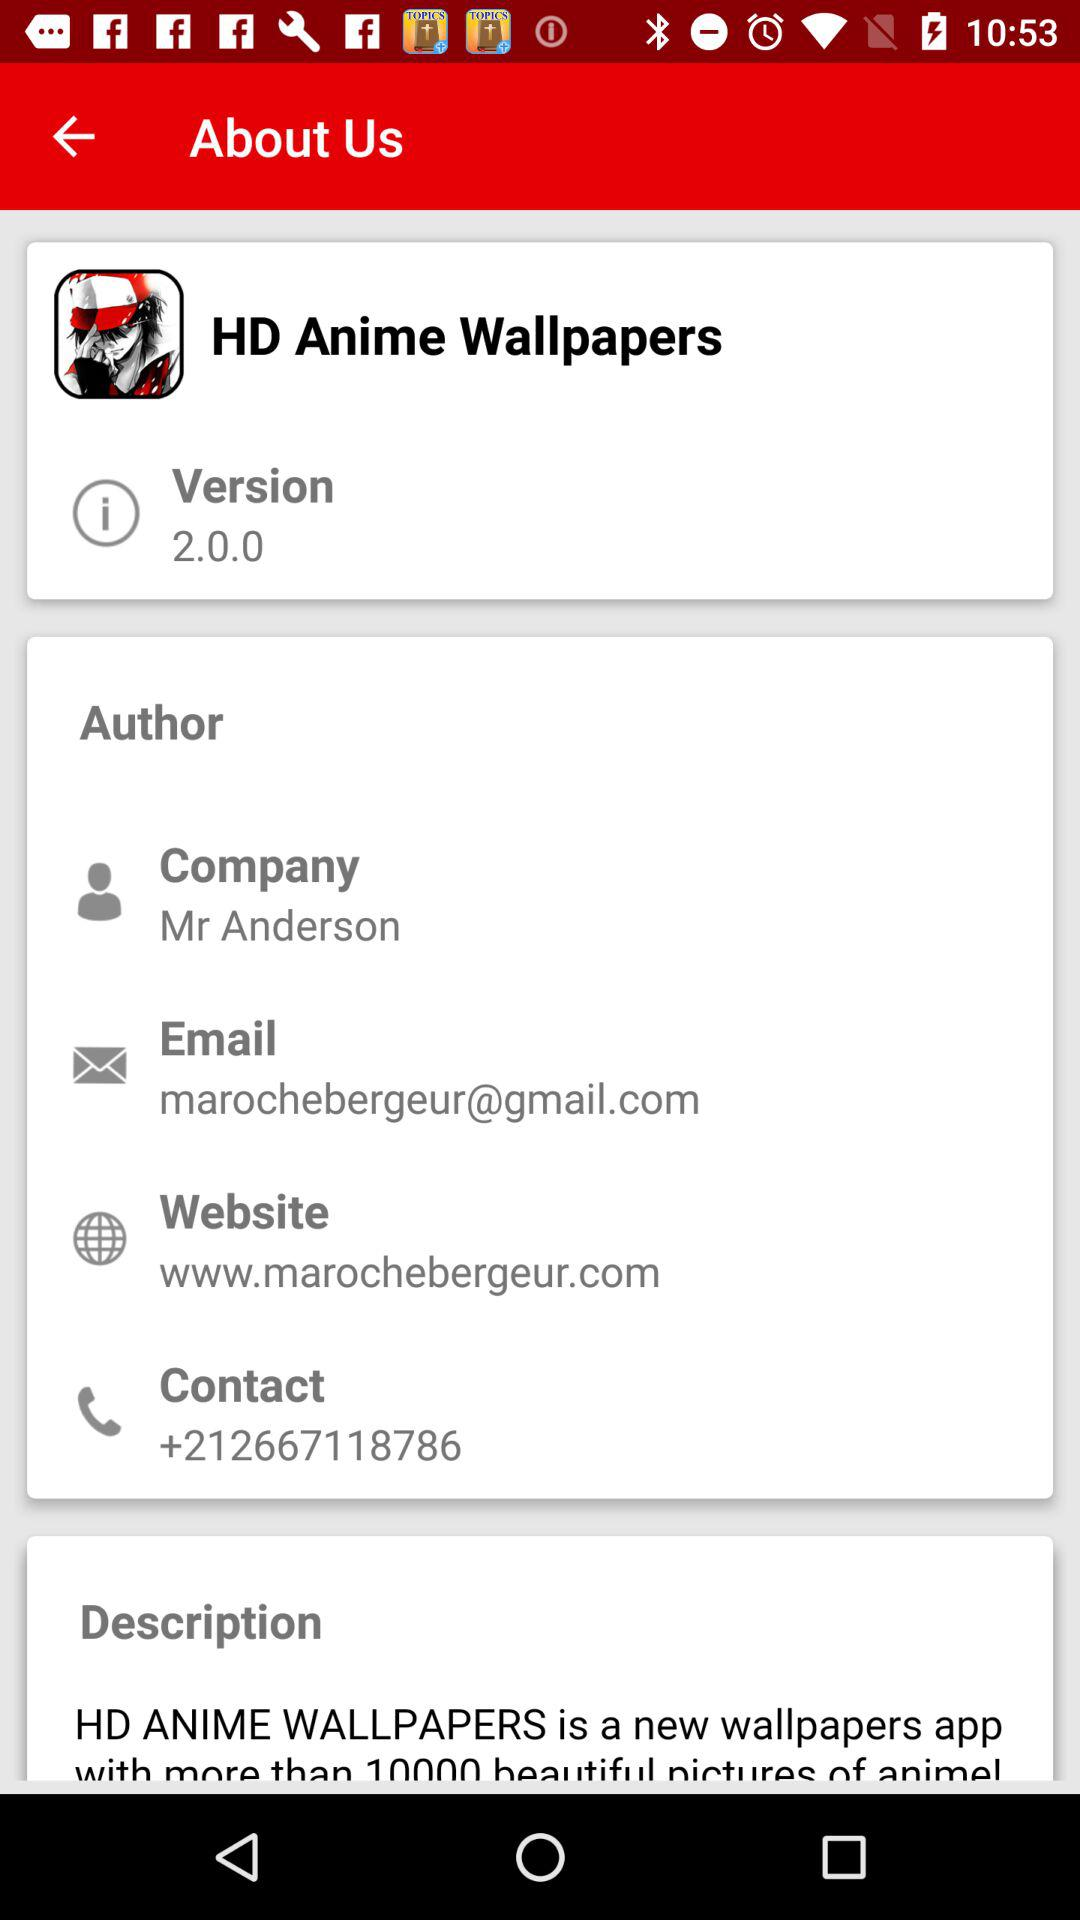What is the version of the app? The version is 2.0.0. 